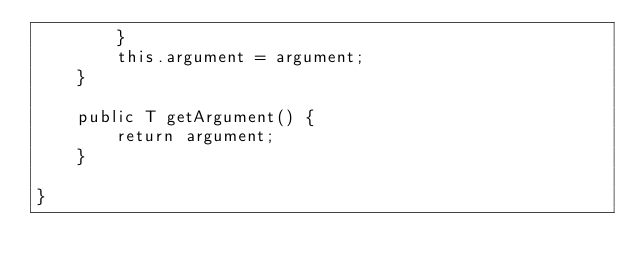<code> <loc_0><loc_0><loc_500><loc_500><_Java_>        }
        this.argument = argument;
    }

    public T getArgument() {
        return argument;
    }

}
</code> 